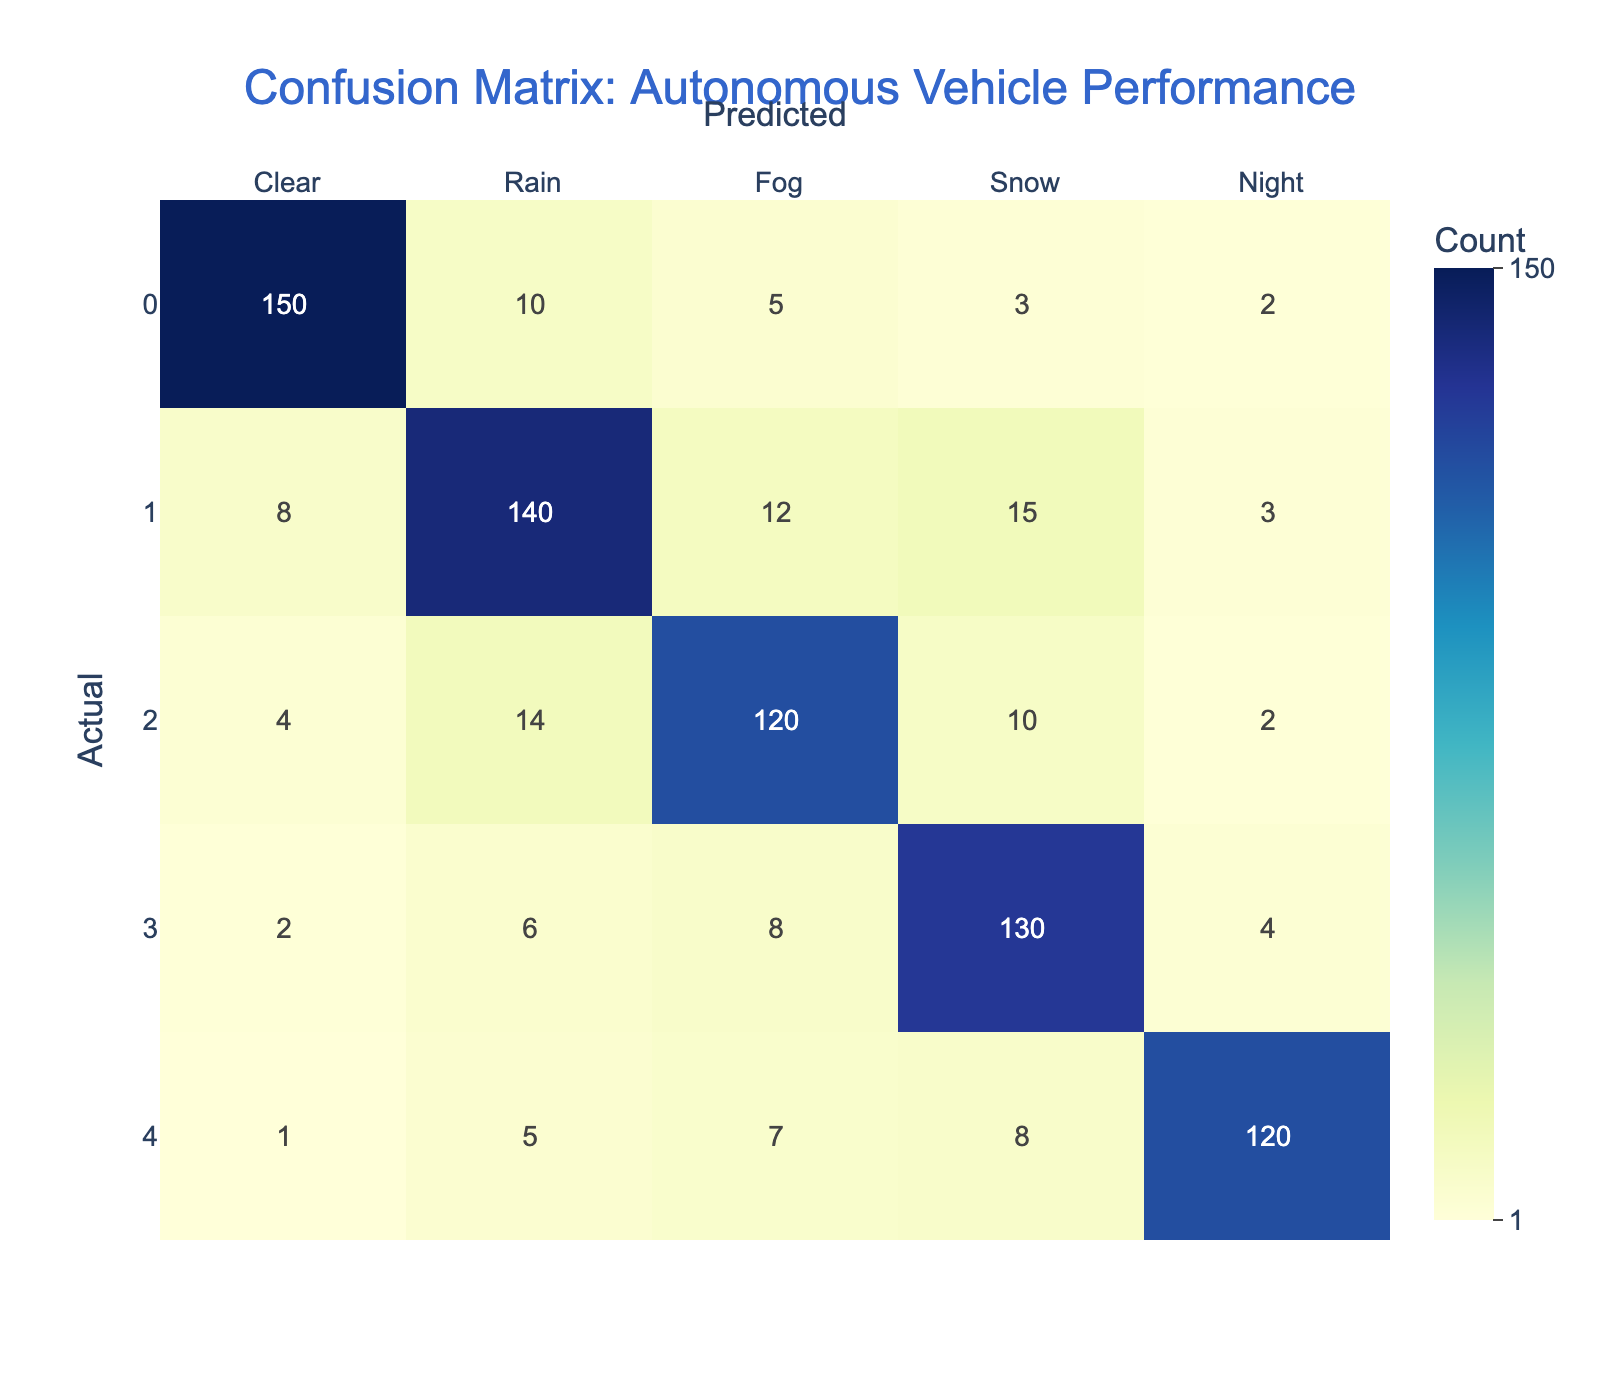What is the number of true positives for the "Fog" condition? The true positives for the "Fog" condition are found in the intersection of the "Fog" row and "Fog" column. This value is 120.
Answer: 120 What is the total number of misclassifications for the "Snow" condition? To find the total number of misclassifications for the "Snow" condition, we sum the values in the "Snow" row, excluding the true positive. The sum is (2 + 6 + 8 + 4) = 20.
Answer: 20 Is the number of correct predictions for "Night" conditions greater than 110? Looking at the "Night" row, the true positive value is 120, which is indeed greater than 110.
Answer: Yes What is the highest number of misclassifications across all weather conditions? The highest number of misclassifications is found by looking for the maximum value in rows that exclude the diagonal (true positives). The maximum is 15 from the "Rain" row (Rain predicted as Snow).
Answer: 15 What is the average number of true positives across all conditions? The true positives for each condition are: Clear (150), Rain (140), Fog (120), Snow (130), Night (120). Summing these gives us 150 + 140 + 120 + 130 + 120 = 660. Dividing by the number of conditions (5) gives an average of 660 / 5 = 132.
Answer: 132 In which weather condition did the autonomous vehicle perform the worst in terms of misclassification? By comparing all the misclassification values, "Snow" has the highest total misclassifications (20), thus indicating the worst performance in terms of misclassifications.
Answer: Snow What is the sum of true positives for "Clear" and "Rain" conditions? The true positives for "Clear" is 150 and for "Rain" is 140. Adding these together gives us 150 + 140 = 290.
Answer: 290 What percentage of the predictions for "Fog" conditions were incorrectly classified? The total predictions for "Fog" is the sum of the entire "Fog" row, which is (4 + 14 + 120 + 10 + 2) = 150. The number of misclassifications is the sum of 4 + 14 + 10 + 2 = 30. The percentage of incorrect classifications is (30 / 150) * 100 = 20%.
Answer: 20% How many predictions were made during "Night" conditions that were classified as "Rain"? The number of predictions classified as "Rain" during "Night" conditions is found in the "Night" row and "Rain" column, which is 5.
Answer: 5 